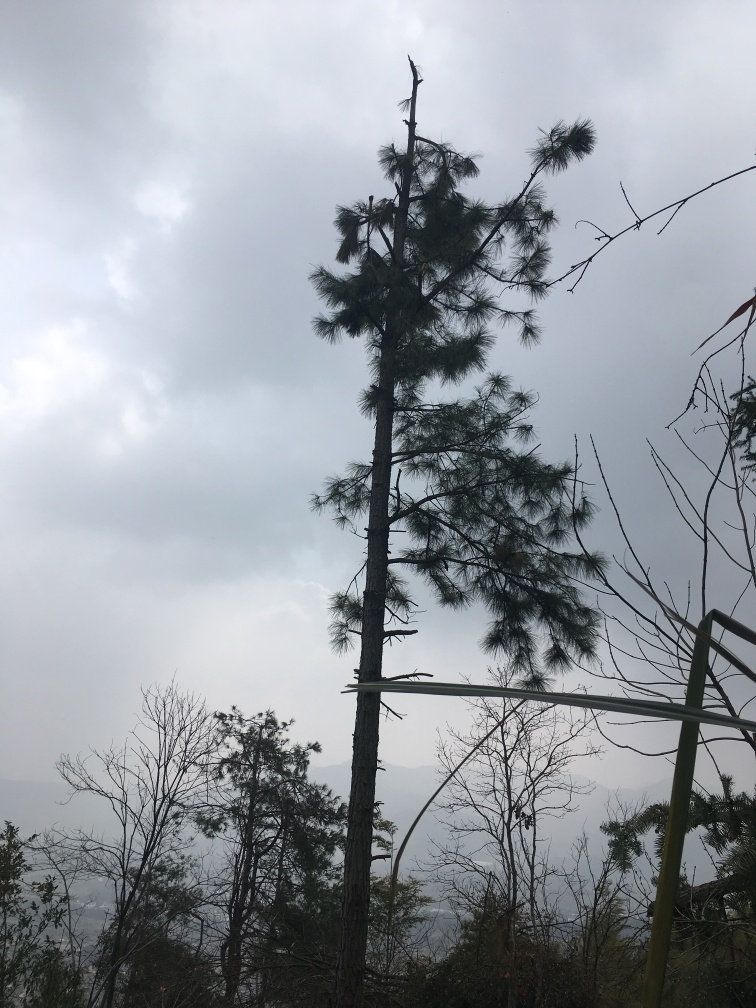Does the background sky have abundant details? Based on the provided image, I would rate the sky's level of detail as moderate; it is neither exceedingly detailed nor entirely lacking. The sky displays varying shades of blue and gray, with soft textures from the cloud formations, thus giving us some details but not an abundance. 